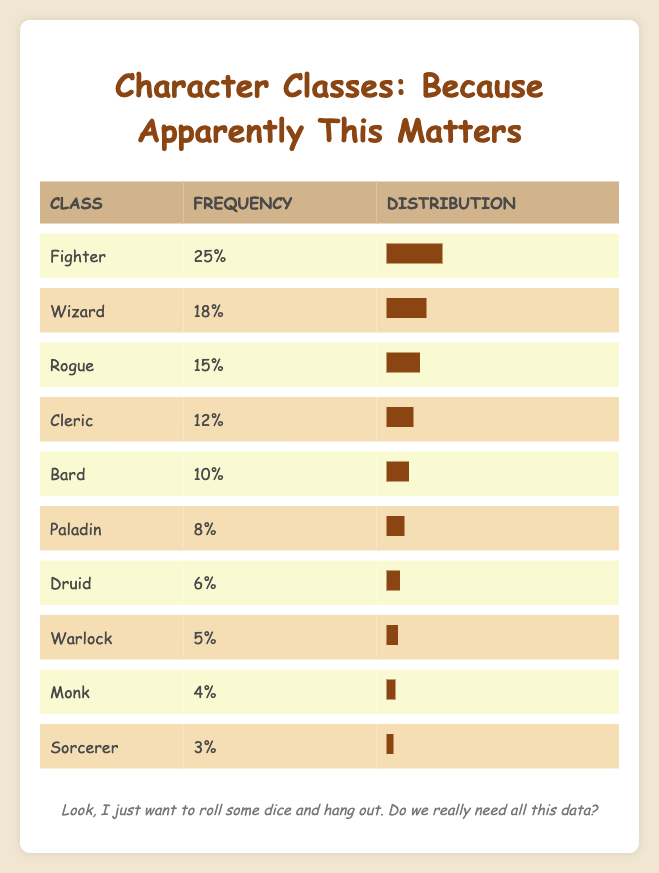What is the most selected class in the campaigns? The table shows that the class "Fighter" has the highest frequency with a value of 25, making it the most selected class.
Answer: Fighter How many players selected Wizard and Cleric combined? To find the total, add the frequencies of Wizard (18) and Cleric (12): 18 + 12 = 30.
Answer: 30 Is it true that more players selected Rogue than Paladin? Yes, the Rogue has a frequency of 15, while the Paladin has a frequency of 8, indicating that more players did indeed select Rogue than Paladin.
Answer: Yes What is the frequency difference between Druid and Sorcerer? The frequency of Druid is 6 and Sorcerer is 3. To find the difference, subtract the frequency of Sorcerer from Druid: 6 - 3 = 3.
Answer: 3 What percentage of players selected Bard or Paladin? The frequency for Bard is 10 and for Paladin is 8. Add these frequencies: 10 + 8 = 18. Next, to find the percentage, we compare this total to the total frequency from all classes, which is 25 + 18 + 15 + 12 + 10 + 8 + 6 + 5 + 4 + 3 =  126. The percentage would be (18 / 126) * 100 = 14.29%.
Answer: 14.29% How many classes have a frequency of 10 or less? From the table, the classes with frequencies of 10 or less are Bard (10), Paladin (8), Druid (6), Warlock (5), Monk (4), and Sorcerer (3). Counting these gives us a total of 6 classes.
Answer: 6 Which classes have a frequency greater than 12? By looking at the frequencies in the table: Fighter (25), Wizard (18), and Rogue (15) have frequencies greater than 12. Therefore, there are three classes satisfying this condition.
Answer: 3 What is the average frequency of the listed character classes? To find the average, sum the frequencies of all classes: 25 + 18 + 15 + 12 + 10 + 8 + 6 + 5 + 4 + 3 =  126. There are 10 classes, so divide: 126 / 10 = 12.6.
Answer: 12.6 Do fewer players favor Warlock than Druid? True, the Warlock has a frequency of 5, while Druid has a frequency of 6, indicating that fewer players favor Warlock compared to Druid.
Answer: Yes 